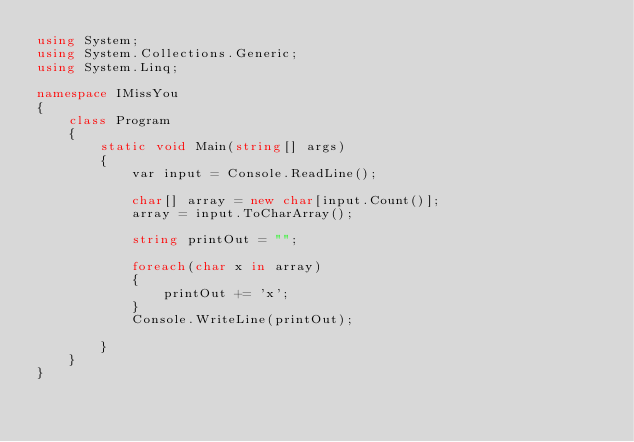Convert code to text. <code><loc_0><loc_0><loc_500><loc_500><_C#_>using System;
using System.Collections.Generic;
using System.Linq;

namespace IMissYou
{
    class Program
    {
        static void Main(string[] args)
        {
            var input = Console.ReadLine();

            char[] array = new char[input.Count()];
            array = input.ToCharArray();

            string printOut = "";

            foreach(char x in array)
            {
                printOut += 'x';
            }
            Console.WriteLine(printOut);
                        
        }
    }
}</code> 